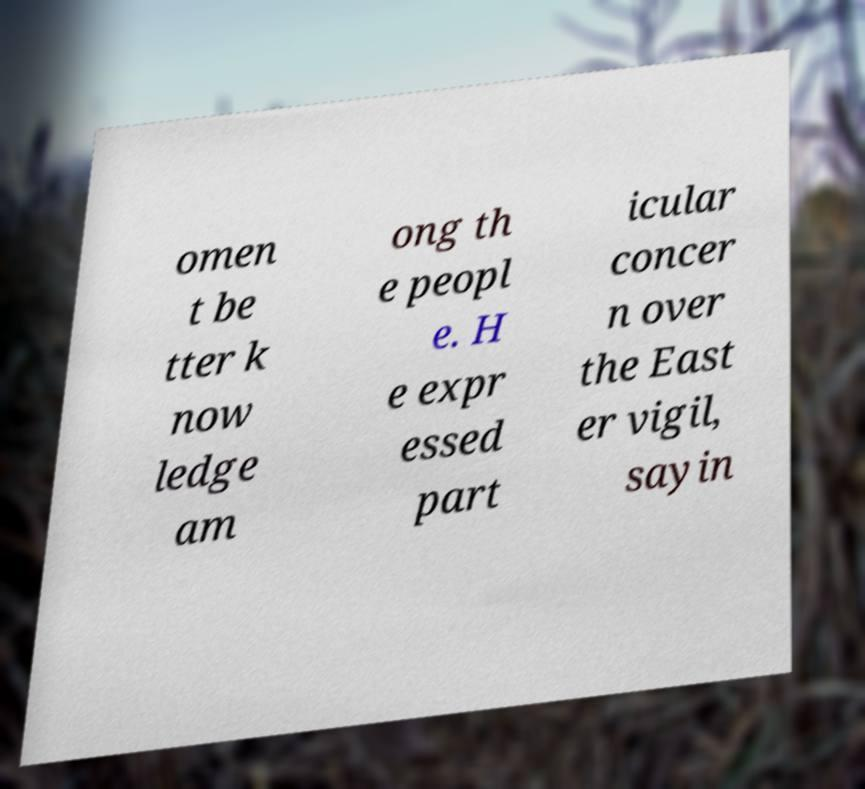Can you read and provide the text displayed in the image?This photo seems to have some interesting text. Can you extract and type it out for me? omen t be tter k now ledge am ong th e peopl e. H e expr essed part icular concer n over the East er vigil, sayin 